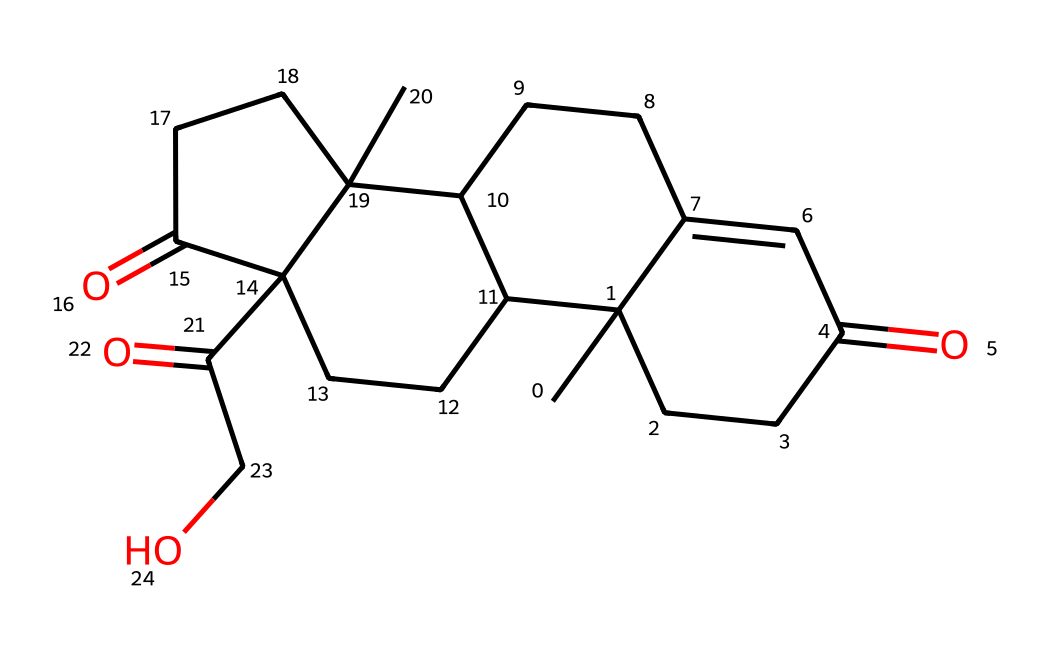What is the molecular formula of cortisol? To derive the molecular formula from the SMILES, we need to identify the atoms present. Counting carbons, hydrogens, and oxygens in the structure leads us to C21H30O5.
Answer: C21H30O5 How many carbon atoms are in cortisol? By analyzing the structure represented by the SMILES, we can count that there are 21 carbon atoms in the chemical makeup of cortisol.
Answer: 21 What type of functional groups are present in cortisol? By examining the structure, we can identify functional groups such as ketones (C=O) and alcohols (–OH). These contribute to the chemical's properties.
Answer: ketones and alcohols How many oxygen atoms does cortisol contain? In the structure derived from the SMILES, we can observe there are 5 oxygen atoms present in cortisol.
Answer: 5 What is the significance of cortisol in relationships? Cortisol is known as a stress hormone, often impacting mood and behavior, which can affect relationships by leading to increased stress responses.
Answer: stress hormone How does the structure of cortisol relate to its function? The molecular structure of cortisol, particularly the hydroxyl and ketone functional groups, allows it to interact with receptors in the body, mediating stress responses and influencing emotional behavior, relevant to relationships.
Answer: mediates stress responses 